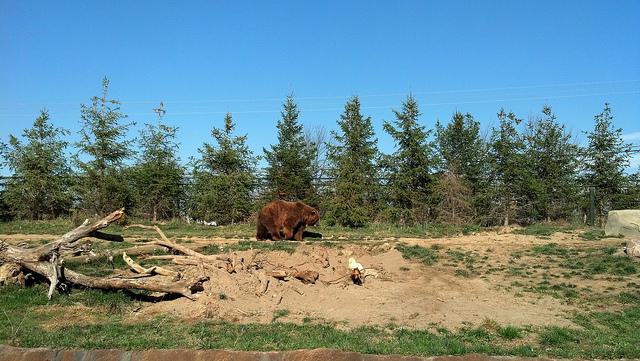Are all the trees living in this photo?
Write a very short answer. No. What type of trees are these?
Give a very brief answer. Pine. Is this animal in the wild?
Give a very brief answer. Yes. 